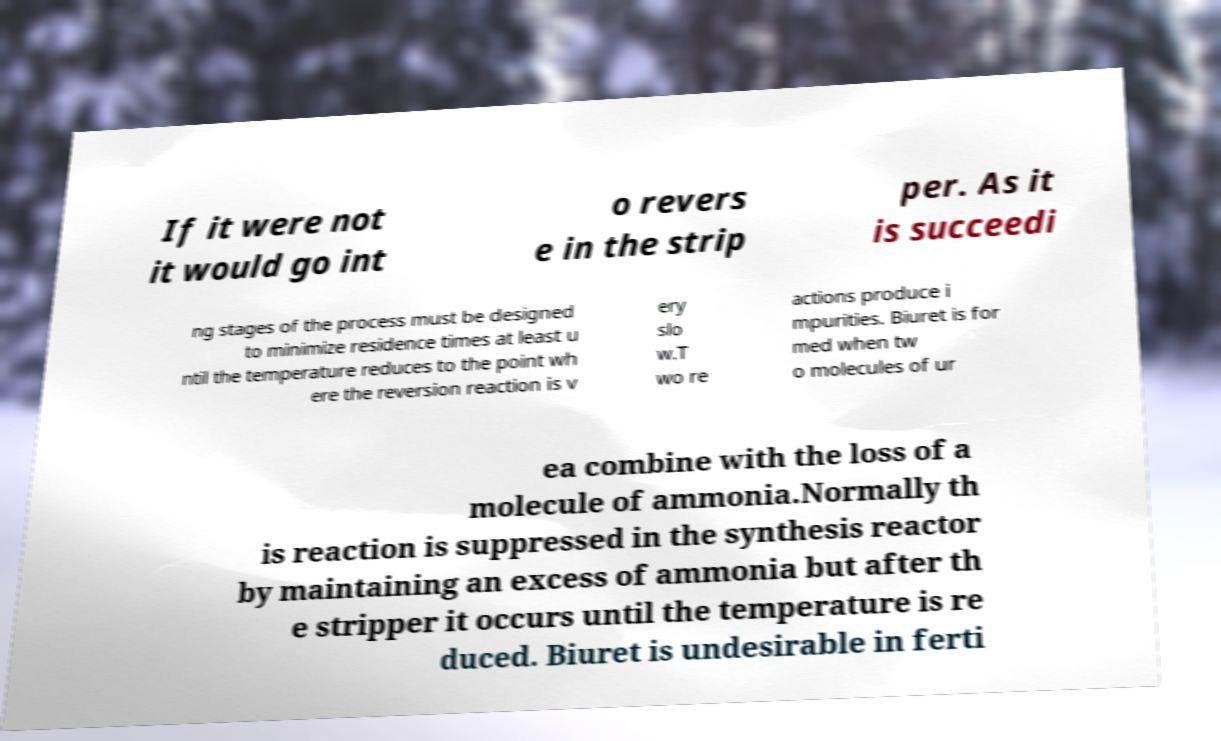I need the written content from this picture converted into text. Can you do that? If it were not it would go int o revers e in the strip per. As it is succeedi ng stages of the process must be designed to minimize residence times at least u ntil the temperature reduces to the point wh ere the reversion reaction is v ery slo w.T wo re actions produce i mpurities. Biuret is for med when tw o molecules of ur ea combine with the loss of a molecule of ammonia.Normally th is reaction is suppressed in the synthesis reactor by maintaining an excess of ammonia but after th e stripper it occurs until the temperature is re duced. Biuret is undesirable in ferti 